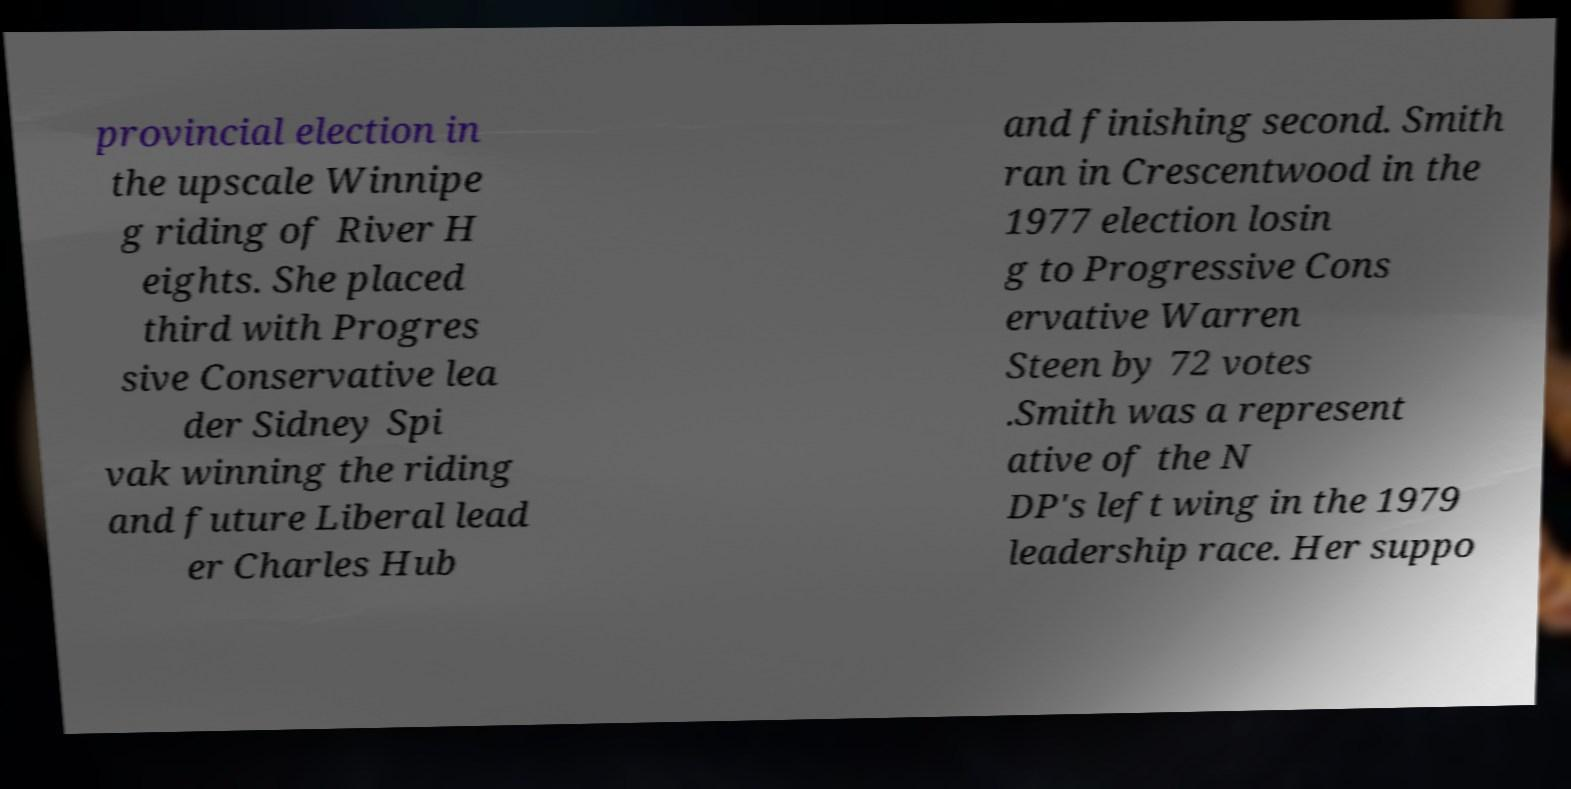Could you assist in decoding the text presented in this image and type it out clearly? provincial election in the upscale Winnipe g riding of River H eights. She placed third with Progres sive Conservative lea der Sidney Spi vak winning the riding and future Liberal lead er Charles Hub and finishing second. Smith ran in Crescentwood in the 1977 election losin g to Progressive Cons ervative Warren Steen by 72 votes .Smith was a represent ative of the N DP's left wing in the 1979 leadership race. Her suppo 